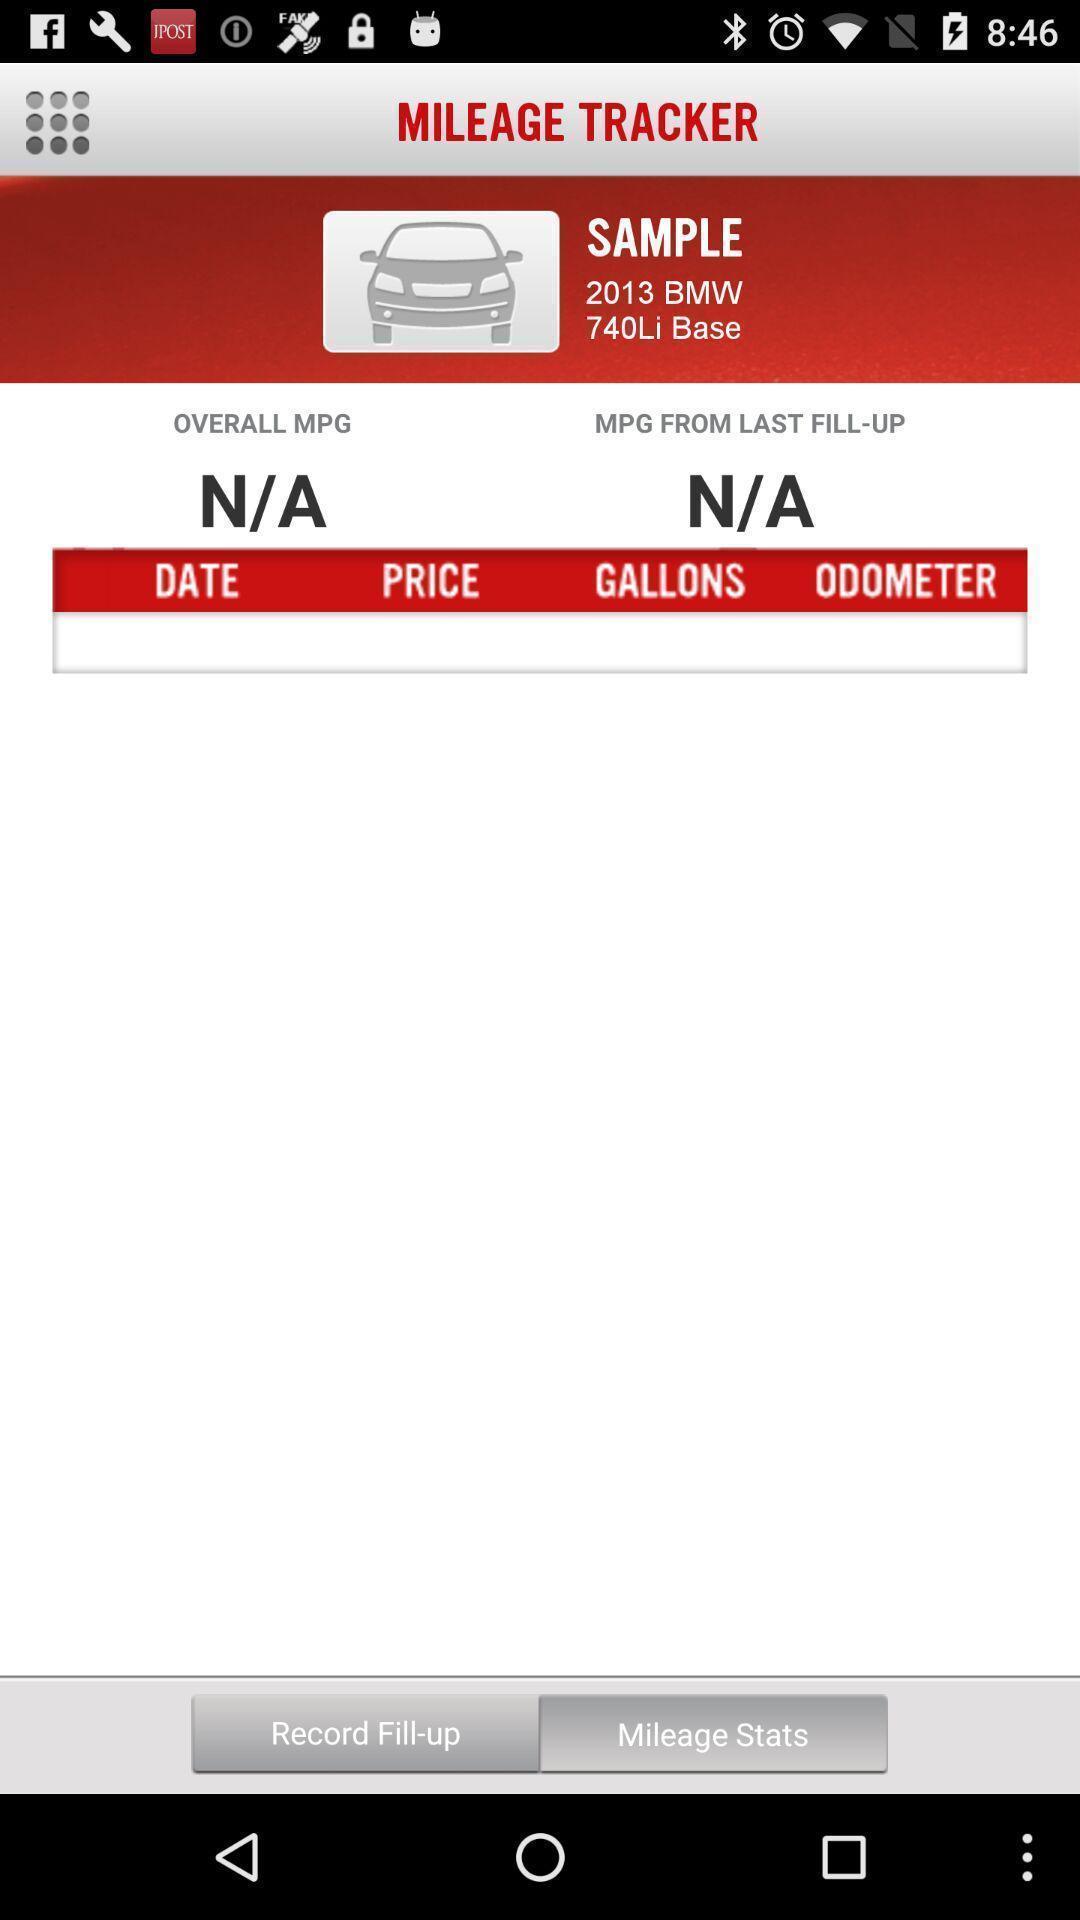Provide a detailed account of this screenshot. Page showing mileage tracker app. 